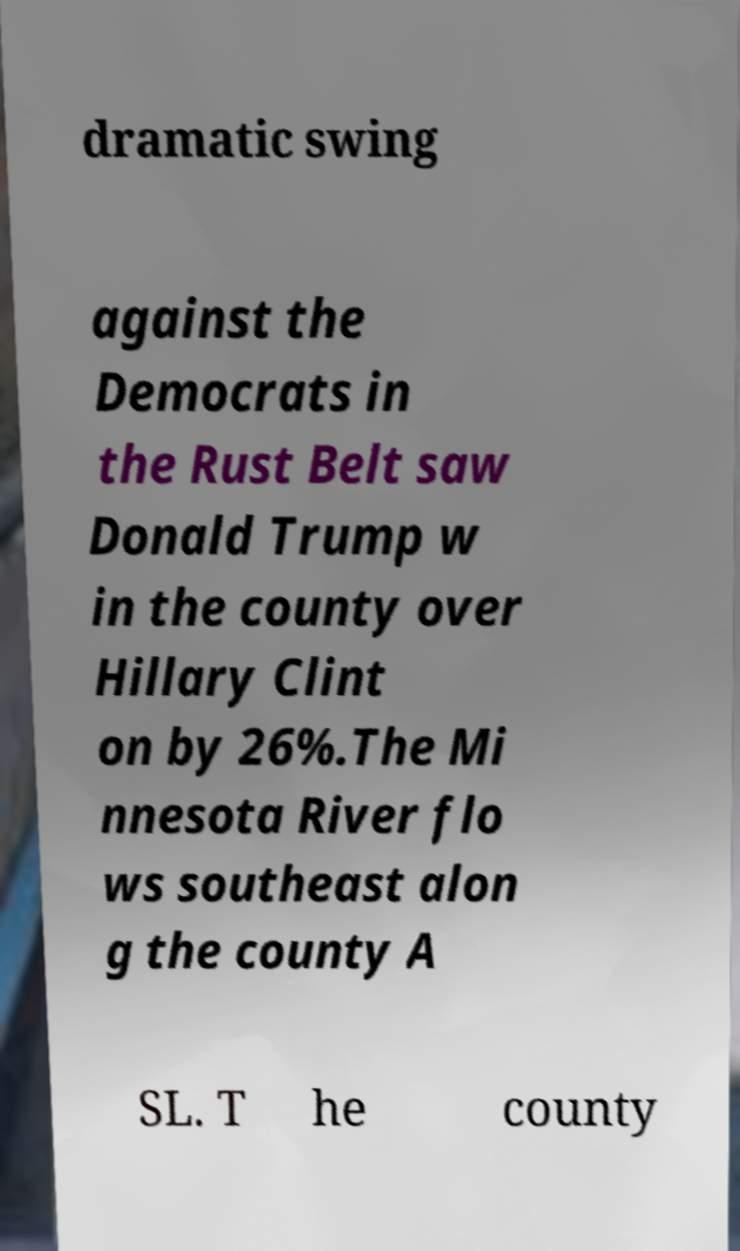Can you accurately transcribe the text from the provided image for me? dramatic swing against the Democrats in the Rust Belt saw Donald Trump w in the county over Hillary Clint on by 26%.The Mi nnesota River flo ws southeast alon g the county A SL. T he county 